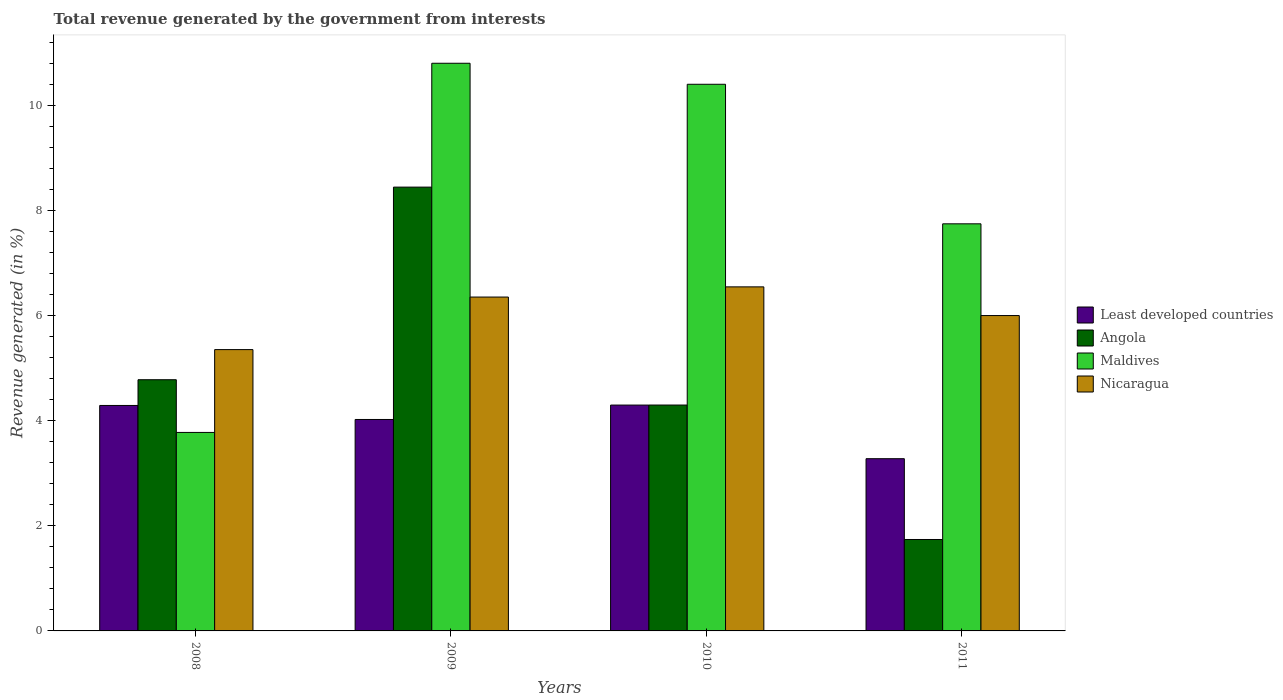Are the number of bars per tick equal to the number of legend labels?
Provide a succinct answer. Yes. How many bars are there on the 3rd tick from the right?
Your answer should be very brief. 4. In how many cases, is the number of bars for a given year not equal to the number of legend labels?
Provide a succinct answer. 0. What is the total revenue generated in Least developed countries in 2009?
Provide a short and direct response. 4.02. Across all years, what is the maximum total revenue generated in Nicaragua?
Make the answer very short. 6.55. Across all years, what is the minimum total revenue generated in Least developed countries?
Keep it short and to the point. 3.28. In which year was the total revenue generated in Nicaragua maximum?
Provide a succinct answer. 2010. What is the total total revenue generated in Least developed countries in the graph?
Your response must be concise. 15.89. What is the difference between the total revenue generated in Nicaragua in 2008 and that in 2009?
Make the answer very short. -1. What is the difference between the total revenue generated in Least developed countries in 2008 and the total revenue generated in Angola in 2011?
Your answer should be very brief. 2.55. What is the average total revenue generated in Nicaragua per year?
Provide a short and direct response. 6.06. In the year 2011, what is the difference between the total revenue generated in Nicaragua and total revenue generated in Least developed countries?
Your answer should be very brief. 2.72. What is the ratio of the total revenue generated in Maldives in 2009 to that in 2010?
Your answer should be very brief. 1.04. What is the difference between the highest and the second highest total revenue generated in Angola?
Keep it short and to the point. 3.66. What is the difference between the highest and the lowest total revenue generated in Nicaragua?
Ensure brevity in your answer.  1.19. Is the sum of the total revenue generated in Angola in 2009 and 2010 greater than the maximum total revenue generated in Maldives across all years?
Your response must be concise. Yes. Is it the case that in every year, the sum of the total revenue generated in Least developed countries and total revenue generated in Nicaragua is greater than the sum of total revenue generated in Angola and total revenue generated in Maldives?
Ensure brevity in your answer.  Yes. What does the 1st bar from the left in 2010 represents?
Your answer should be compact. Least developed countries. What does the 2nd bar from the right in 2008 represents?
Offer a terse response. Maldives. How many bars are there?
Provide a short and direct response. 16. Are all the bars in the graph horizontal?
Make the answer very short. No. What is the difference between two consecutive major ticks on the Y-axis?
Your answer should be very brief. 2. Are the values on the major ticks of Y-axis written in scientific E-notation?
Provide a succinct answer. No. Does the graph contain any zero values?
Keep it short and to the point. No. What is the title of the graph?
Provide a short and direct response. Total revenue generated by the government from interests. Does "St. Lucia" appear as one of the legend labels in the graph?
Make the answer very short. No. What is the label or title of the X-axis?
Your response must be concise. Years. What is the label or title of the Y-axis?
Keep it short and to the point. Revenue generated (in %). What is the Revenue generated (in %) in Least developed countries in 2008?
Provide a short and direct response. 4.29. What is the Revenue generated (in %) of Angola in 2008?
Your answer should be very brief. 4.78. What is the Revenue generated (in %) in Maldives in 2008?
Offer a very short reply. 3.78. What is the Revenue generated (in %) of Nicaragua in 2008?
Provide a short and direct response. 5.35. What is the Revenue generated (in %) of Least developed countries in 2009?
Keep it short and to the point. 4.02. What is the Revenue generated (in %) in Angola in 2009?
Ensure brevity in your answer.  8.44. What is the Revenue generated (in %) of Maldives in 2009?
Offer a very short reply. 10.8. What is the Revenue generated (in %) of Nicaragua in 2009?
Offer a terse response. 6.35. What is the Revenue generated (in %) in Least developed countries in 2010?
Give a very brief answer. 4.3. What is the Revenue generated (in %) of Angola in 2010?
Offer a terse response. 4.3. What is the Revenue generated (in %) in Maldives in 2010?
Give a very brief answer. 10.4. What is the Revenue generated (in %) in Nicaragua in 2010?
Your answer should be very brief. 6.55. What is the Revenue generated (in %) in Least developed countries in 2011?
Ensure brevity in your answer.  3.28. What is the Revenue generated (in %) of Angola in 2011?
Make the answer very short. 1.74. What is the Revenue generated (in %) in Maldives in 2011?
Provide a short and direct response. 7.75. What is the Revenue generated (in %) in Nicaragua in 2011?
Your response must be concise. 6. Across all years, what is the maximum Revenue generated (in %) in Least developed countries?
Make the answer very short. 4.3. Across all years, what is the maximum Revenue generated (in %) of Angola?
Make the answer very short. 8.44. Across all years, what is the maximum Revenue generated (in %) in Maldives?
Keep it short and to the point. 10.8. Across all years, what is the maximum Revenue generated (in %) of Nicaragua?
Make the answer very short. 6.55. Across all years, what is the minimum Revenue generated (in %) in Least developed countries?
Offer a terse response. 3.28. Across all years, what is the minimum Revenue generated (in %) in Angola?
Ensure brevity in your answer.  1.74. Across all years, what is the minimum Revenue generated (in %) in Maldives?
Your response must be concise. 3.78. Across all years, what is the minimum Revenue generated (in %) of Nicaragua?
Your answer should be compact. 5.35. What is the total Revenue generated (in %) in Least developed countries in the graph?
Your response must be concise. 15.89. What is the total Revenue generated (in %) in Angola in the graph?
Offer a very short reply. 19.26. What is the total Revenue generated (in %) in Maldives in the graph?
Provide a succinct answer. 32.72. What is the total Revenue generated (in %) of Nicaragua in the graph?
Ensure brevity in your answer.  24.25. What is the difference between the Revenue generated (in %) of Least developed countries in 2008 and that in 2009?
Your answer should be very brief. 0.27. What is the difference between the Revenue generated (in %) in Angola in 2008 and that in 2009?
Your response must be concise. -3.66. What is the difference between the Revenue generated (in %) in Maldives in 2008 and that in 2009?
Offer a very short reply. -7.02. What is the difference between the Revenue generated (in %) in Nicaragua in 2008 and that in 2009?
Your answer should be compact. -1. What is the difference between the Revenue generated (in %) in Least developed countries in 2008 and that in 2010?
Give a very brief answer. -0.01. What is the difference between the Revenue generated (in %) in Angola in 2008 and that in 2010?
Your answer should be very brief. 0.48. What is the difference between the Revenue generated (in %) of Maldives in 2008 and that in 2010?
Offer a terse response. -6.62. What is the difference between the Revenue generated (in %) in Nicaragua in 2008 and that in 2010?
Provide a short and direct response. -1.19. What is the difference between the Revenue generated (in %) in Least developed countries in 2008 and that in 2011?
Your response must be concise. 1.01. What is the difference between the Revenue generated (in %) of Angola in 2008 and that in 2011?
Your answer should be compact. 3.04. What is the difference between the Revenue generated (in %) in Maldives in 2008 and that in 2011?
Keep it short and to the point. -3.97. What is the difference between the Revenue generated (in %) of Nicaragua in 2008 and that in 2011?
Give a very brief answer. -0.65. What is the difference between the Revenue generated (in %) in Least developed countries in 2009 and that in 2010?
Provide a succinct answer. -0.27. What is the difference between the Revenue generated (in %) of Angola in 2009 and that in 2010?
Give a very brief answer. 4.15. What is the difference between the Revenue generated (in %) of Maldives in 2009 and that in 2010?
Your answer should be very brief. 0.4. What is the difference between the Revenue generated (in %) in Nicaragua in 2009 and that in 2010?
Provide a succinct answer. -0.19. What is the difference between the Revenue generated (in %) in Least developed countries in 2009 and that in 2011?
Offer a very short reply. 0.75. What is the difference between the Revenue generated (in %) in Angola in 2009 and that in 2011?
Offer a terse response. 6.7. What is the difference between the Revenue generated (in %) in Maldives in 2009 and that in 2011?
Offer a terse response. 3.05. What is the difference between the Revenue generated (in %) of Nicaragua in 2009 and that in 2011?
Your answer should be compact. 0.35. What is the difference between the Revenue generated (in %) of Least developed countries in 2010 and that in 2011?
Ensure brevity in your answer.  1.02. What is the difference between the Revenue generated (in %) in Angola in 2010 and that in 2011?
Your answer should be very brief. 2.56. What is the difference between the Revenue generated (in %) in Maldives in 2010 and that in 2011?
Provide a short and direct response. 2.65. What is the difference between the Revenue generated (in %) of Nicaragua in 2010 and that in 2011?
Keep it short and to the point. 0.55. What is the difference between the Revenue generated (in %) in Least developed countries in 2008 and the Revenue generated (in %) in Angola in 2009?
Provide a succinct answer. -4.15. What is the difference between the Revenue generated (in %) in Least developed countries in 2008 and the Revenue generated (in %) in Maldives in 2009?
Give a very brief answer. -6.51. What is the difference between the Revenue generated (in %) in Least developed countries in 2008 and the Revenue generated (in %) in Nicaragua in 2009?
Provide a short and direct response. -2.06. What is the difference between the Revenue generated (in %) in Angola in 2008 and the Revenue generated (in %) in Maldives in 2009?
Give a very brief answer. -6.02. What is the difference between the Revenue generated (in %) in Angola in 2008 and the Revenue generated (in %) in Nicaragua in 2009?
Your response must be concise. -1.57. What is the difference between the Revenue generated (in %) of Maldives in 2008 and the Revenue generated (in %) of Nicaragua in 2009?
Provide a succinct answer. -2.58. What is the difference between the Revenue generated (in %) in Least developed countries in 2008 and the Revenue generated (in %) in Angola in 2010?
Offer a very short reply. -0.01. What is the difference between the Revenue generated (in %) of Least developed countries in 2008 and the Revenue generated (in %) of Maldives in 2010?
Give a very brief answer. -6.11. What is the difference between the Revenue generated (in %) in Least developed countries in 2008 and the Revenue generated (in %) in Nicaragua in 2010?
Your answer should be compact. -2.26. What is the difference between the Revenue generated (in %) in Angola in 2008 and the Revenue generated (in %) in Maldives in 2010?
Your answer should be very brief. -5.62. What is the difference between the Revenue generated (in %) in Angola in 2008 and the Revenue generated (in %) in Nicaragua in 2010?
Your response must be concise. -1.77. What is the difference between the Revenue generated (in %) in Maldives in 2008 and the Revenue generated (in %) in Nicaragua in 2010?
Your response must be concise. -2.77. What is the difference between the Revenue generated (in %) of Least developed countries in 2008 and the Revenue generated (in %) of Angola in 2011?
Ensure brevity in your answer.  2.55. What is the difference between the Revenue generated (in %) of Least developed countries in 2008 and the Revenue generated (in %) of Maldives in 2011?
Keep it short and to the point. -3.46. What is the difference between the Revenue generated (in %) of Least developed countries in 2008 and the Revenue generated (in %) of Nicaragua in 2011?
Provide a succinct answer. -1.71. What is the difference between the Revenue generated (in %) of Angola in 2008 and the Revenue generated (in %) of Maldives in 2011?
Give a very brief answer. -2.97. What is the difference between the Revenue generated (in %) of Angola in 2008 and the Revenue generated (in %) of Nicaragua in 2011?
Your answer should be very brief. -1.22. What is the difference between the Revenue generated (in %) in Maldives in 2008 and the Revenue generated (in %) in Nicaragua in 2011?
Your answer should be compact. -2.22. What is the difference between the Revenue generated (in %) in Least developed countries in 2009 and the Revenue generated (in %) in Angola in 2010?
Keep it short and to the point. -0.27. What is the difference between the Revenue generated (in %) of Least developed countries in 2009 and the Revenue generated (in %) of Maldives in 2010?
Offer a terse response. -6.38. What is the difference between the Revenue generated (in %) in Least developed countries in 2009 and the Revenue generated (in %) in Nicaragua in 2010?
Make the answer very short. -2.52. What is the difference between the Revenue generated (in %) in Angola in 2009 and the Revenue generated (in %) in Maldives in 2010?
Provide a succinct answer. -1.96. What is the difference between the Revenue generated (in %) of Angola in 2009 and the Revenue generated (in %) of Nicaragua in 2010?
Ensure brevity in your answer.  1.9. What is the difference between the Revenue generated (in %) in Maldives in 2009 and the Revenue generated (in %) in Nicaragua in 2010?
Your response must be concise. 4.25. What is the difference between the Revenue generated (in %) in Least developed countries in 2009 and the Revenue generated (in %) in Angola in 2011?
Offer a very short reply. 2.28. What is the difference between the Revenue generated (in %) of Least developed countries in 2009 and the Revenue generated (in %) of Maldives in 2011?
Keep it short and to the point. -3.72. What is the difference between the Revenue generated (in %) in Least developed countries in 2009 and the Revenue generated (in %) in Nicaragua in 2011?
Offer a very short reply. -1.98. What is the difference between the Revenue generated (in %) in Angola in 2009 and the Revenue generated (in %) in Maldives in 2011?
Provide a succinct answer. 0.7. What is the difference between the Revenue generated (in %) of Angola in 2009 and the Revenue generated (in %) of Nicaragua in 2011?
Your answer should be very brief. 2.44. What is the difference between the Revenue generated (in %) of Maldives in 2009 and the Revenue generated (in %) of Nicaragua in 2011?
Your response must be concise. 4.8. What is the difference between the Revenue generated (in %) in Least developed countries in 2010 and the Revenue generated (in %) in Angola in 2011?
Offer a very short reply. 2.56. What is the difference between the Revenue generated (in %) of Least developed countries in 2010 and the Revenue generated (in %) of Maldives in 2011?
Provide a succinct answer. -3.45. What is the difference between the Revenue generated (in %) of Least developed countries in 2010 and the Revenue generated (in %) of Nicaragua in 2011?
Provide a succinct answer. -1.7. What is the difference between the Revenue generated (in %) of Angola in 2010 and the Revenue generated (in %) of Maldives in 2011?
Your answer should be very brief. -3.45. What is the difference between the Revenue generated (in %) in Angola in 2010 and the Revenue generated (in %) in Nicaragua in 2011?
Your answer should be compact. -1.7. What is the difference between the Revenue generated (in %) of Maldives in 2010 and the Revenue generated (in %) of Nicaragua in 2011?
Offer a terse response. 4.4. What is the average Revenue generated (in %) in Least developed countries per year?
Ensure brevity in your answer.  3.97. What is the average Revenue generated (in %) of Angola per year?
Give a very brief answer. 4.82. What is the average Revenue generated (in %) of Maldives per year?
Make the answer very short. 8.18. What is the average Revenue generated (in %) in Nicaragua per year?
Keep it short and to the point. 6.06. In the year 2008, what is the difference between the Revenue generated (in %) in Least developed countries and Revenue generated (in %) in Angola?
Ensure brevity in your answer.  -0.49. In the year 2008, what is the difference between the Revenue generated (in %) in Least developed countries and Revenue generated (in %) in Maldives?
Keep it short and to the point. 0.51. In the year 2008, what is the difference between the Revenue generated (in %) in Least developed countries and Revenue generated (in %) in Nicaragua?
Your answer should be very brief. -1.06. In the year 2008, what is the difference between the Revenue generated (in %) in Angola and Revenue generated (in %) in Nicaragua?
Your answer should be compact. -0.57. In the year 2008, what is the difference between the Revenue generated (in %) of Maldives and Revenue generated (in %) of Nicaragua?
Provide a succinct answer. -1.58. In the year 2009, what is the difference between the Revenue generated (in %) of Least developed countries and Revenue generated (in %) of Angola?
Provide a short and direct response. -4.42. In the year 2009, what is the difference between the Revenue generated (in %) in Least developed countries and Revenue generated (in %) in Maldives?
Ensure brevity in your answer.  -6.78. In the year 2009, what is the difference between the Revenue generated (in %) of Least developed countries and Revenue generated (in %) of Nicaragua?
Give a very brief answer. -2.33. In the year 2009, what is the difference between the Revenue generated (in %) in Angola and Revenue generated (in %) in Maldives?
Your answer should be very brief. -2.36. In the year 2009, what is the difference between the Revenue generated (in %) of Angola and Revenue generated (in %) of Nicaragua?
Your response must be concise. 2.09. In the year 2009, what is the difference between the Revenue generated (in %) in Maldives and Revenue generated (in %) in Nicaragua?
Keep it short and to the point. 4.45. In the year 2010, what is the difference between the Revenue generated (in %) in Least developed countries and Revenue generated (in %) in Angola?
Provide a short and direct response. -0. In the year 2010, what is the difference between the Revenue generated (in %) in Least developed countries and Revenue generated (in %) in Maldives?
Your answer should be very brief. -6.1. In the year 2010, what is the difference between the Revenue generated (in %) of Least developed countries and Revenue generated (in %) of Nicaragua?
Offer a very short reply. -2.25. In the year 2010, what is the difference between the Revenue generated (in %) of Angola and Revenue generated (in %) of Maldives?
Provide a succinct answer. -6.1. In the year 2010, what is the difference between the Revenue generated (in %) of Angola and Revenue generated (in %) of Nicaragua?
Your answer should be very brief. -2.25. In the year 2010, what is the difference between the Revenue generated (in %) of Maldives and Revenue generated (in %) of Nicaragua?
Give a very brief answer. 3.85. In the year 2011, what is the difference between the Revenue generated (in %) in Least developed countries and Revenue generated (in %) in Angola?
Your response must be concise. 1.54. In the year 2011, what is the difference between the Revenue generated (in %) in Least developed countries and Revenue generated (in %) in Maldives?
Provide a succinct answer. -4.47. In the year 2011, what is the difference between the Revenue generated (in %) of Least developed countries and Revenue generated (in %) of Nicaragua?
Offer a very short reply. -2.72. In the year 2011, what is the difference between the Revenue generated (in %) of Angola and Revenue generated (in %) of Maldives?
Provide a succinct answer. -6.01. In the year 2011, what is the difference between the Revenue generated (in %) of Angola and Revenue generated (in %) of Nicaragua?
Offer a very short reply. -4.26. In the year 2011, what is the difference between the Revenue generated (in %) of Maldives and Revenue generated (in %) of Nicaragua?
Your answer should be compact. 1.75. What is the ratio of the Revenue generated (in %) of Least developed countries in 2008 to that in 2009?
Your answer should be very brief. 1.07. What is the ratio of the Revenue generated (in %) of Angola in 2008 to that in 2009?
Offer a terse response. 0.57. What is the ratio of the Revenue generated (in %) of Maldives in 2008 to that in 2009?
Offer a terse response. 0.35. What is the ratio of the Revenue generated (in %) in Nicaragua in 2008 to that in 2009?
Your answer should be compact. 0.84. What is the ratio of the Revenue generated (in %) of Angola in 2008 to that in 2010?
Offer a terse response. 1.11. What is the ratio of the Revenue generated (in %) in Maldives in 2008 to that in 2010?
Make the answer very short. 0.36. What is the ratio of the Revenue generated (in %) of Nicaragua in 2008 to that in 2010?
Your answer should be compact. 0.82. What is the ratio of the Revenue generated (in %) of Least developed countries in 2008 to that in 2011?
Keep it short and to the point. 1.31. What is the ratio of the Revenue generated (in %) of Angola in 2008 to that in 2011?
Offer a very short reply. 2.75. What is the ratio of the Revenue generated (in %) in Maldives in 2008 to that in 2011?
Make the answer very short. 0.49. What is the ratio of the Revenue generated (in %) in Nicaragua in 2008 to that in 2011?
Your answer should be compact. 0.89. What is the ratio of the Revenue generated (in %) in Least developed countries in 2009 to that in 2010?
Your answer should be very brief. 0.94. What is the ratio of the Revenue generated (in %) of Angola in 2009 to that in 2010?
Your response must be concise. 1.96. What is the ratio of the Revenue generated (in %) of Nicaragua in 2009 to that in 2010?
Offer a very short reply. 0.97. What is the ratio of the Revenue generated (in %) in Least developed countries in 2009 to that in 2011?
Offer a terse response. 1.23. What is the ratio of the Revenue generated (in %) of Angola in 2009 to that in 2011?
Make the answer very short. 4.85. What is the ratio of the Revenue generated (in %) of Maldives in 2009 to that in 2011?
Your answer should be very brief. 1.39. What is the ratio of the Revenue generated (in %) of Nicaragua in 2009 to that in 2011?
Keep it short and to the point. 1.06. What is the ratio of the Revenue generated (in %) in Least developed countries in 2010 to that in 2011?
Make the answer very short. 1.31. What is the ratio of the Revenue generated (in %) of Angola in 2010 to that in 2011?
Your answer should be compact. 2.47. What is the ratio of the Revenue generated (in %) of Maldives in 2010 to that in 2011?
Ensure brevity in your answer.  1.34. What is the ratio of the Revenue generated (in %) in Nicaragua in 2010 to that in 2011?
Your answer should be very brief. 1.09. What is the difference between the highest and the second highest Revenue generated (in %) in Least developed countries?
Provide a short and direct response. 0.01. What is the difference between the highest and the second highest Revenue generated (in %) of Angola?
Keep it short and to the point. 3.66. What is the difference between the highest and the second highest Revenue generated (in %) in Nicaragua?
Keep it short and to the point. 0.19. What is the difference between the highest and the lowest Revenue generated (in %) of Least developed countries?
Offer a very short reply. 1.02. What is the difference between the highest and the lowest Revenue generated (in %) in Angola?
Keep it short and to the point. 6.7. What is the difference between the highest and the lowest Revenue generated (in %) of Maldives?
Give a very brief answer. 7.02. What is the difference between the highest and the lowest Revenue generated (in %) of Nicaragua?
Your answer should be compact. 1.19. 